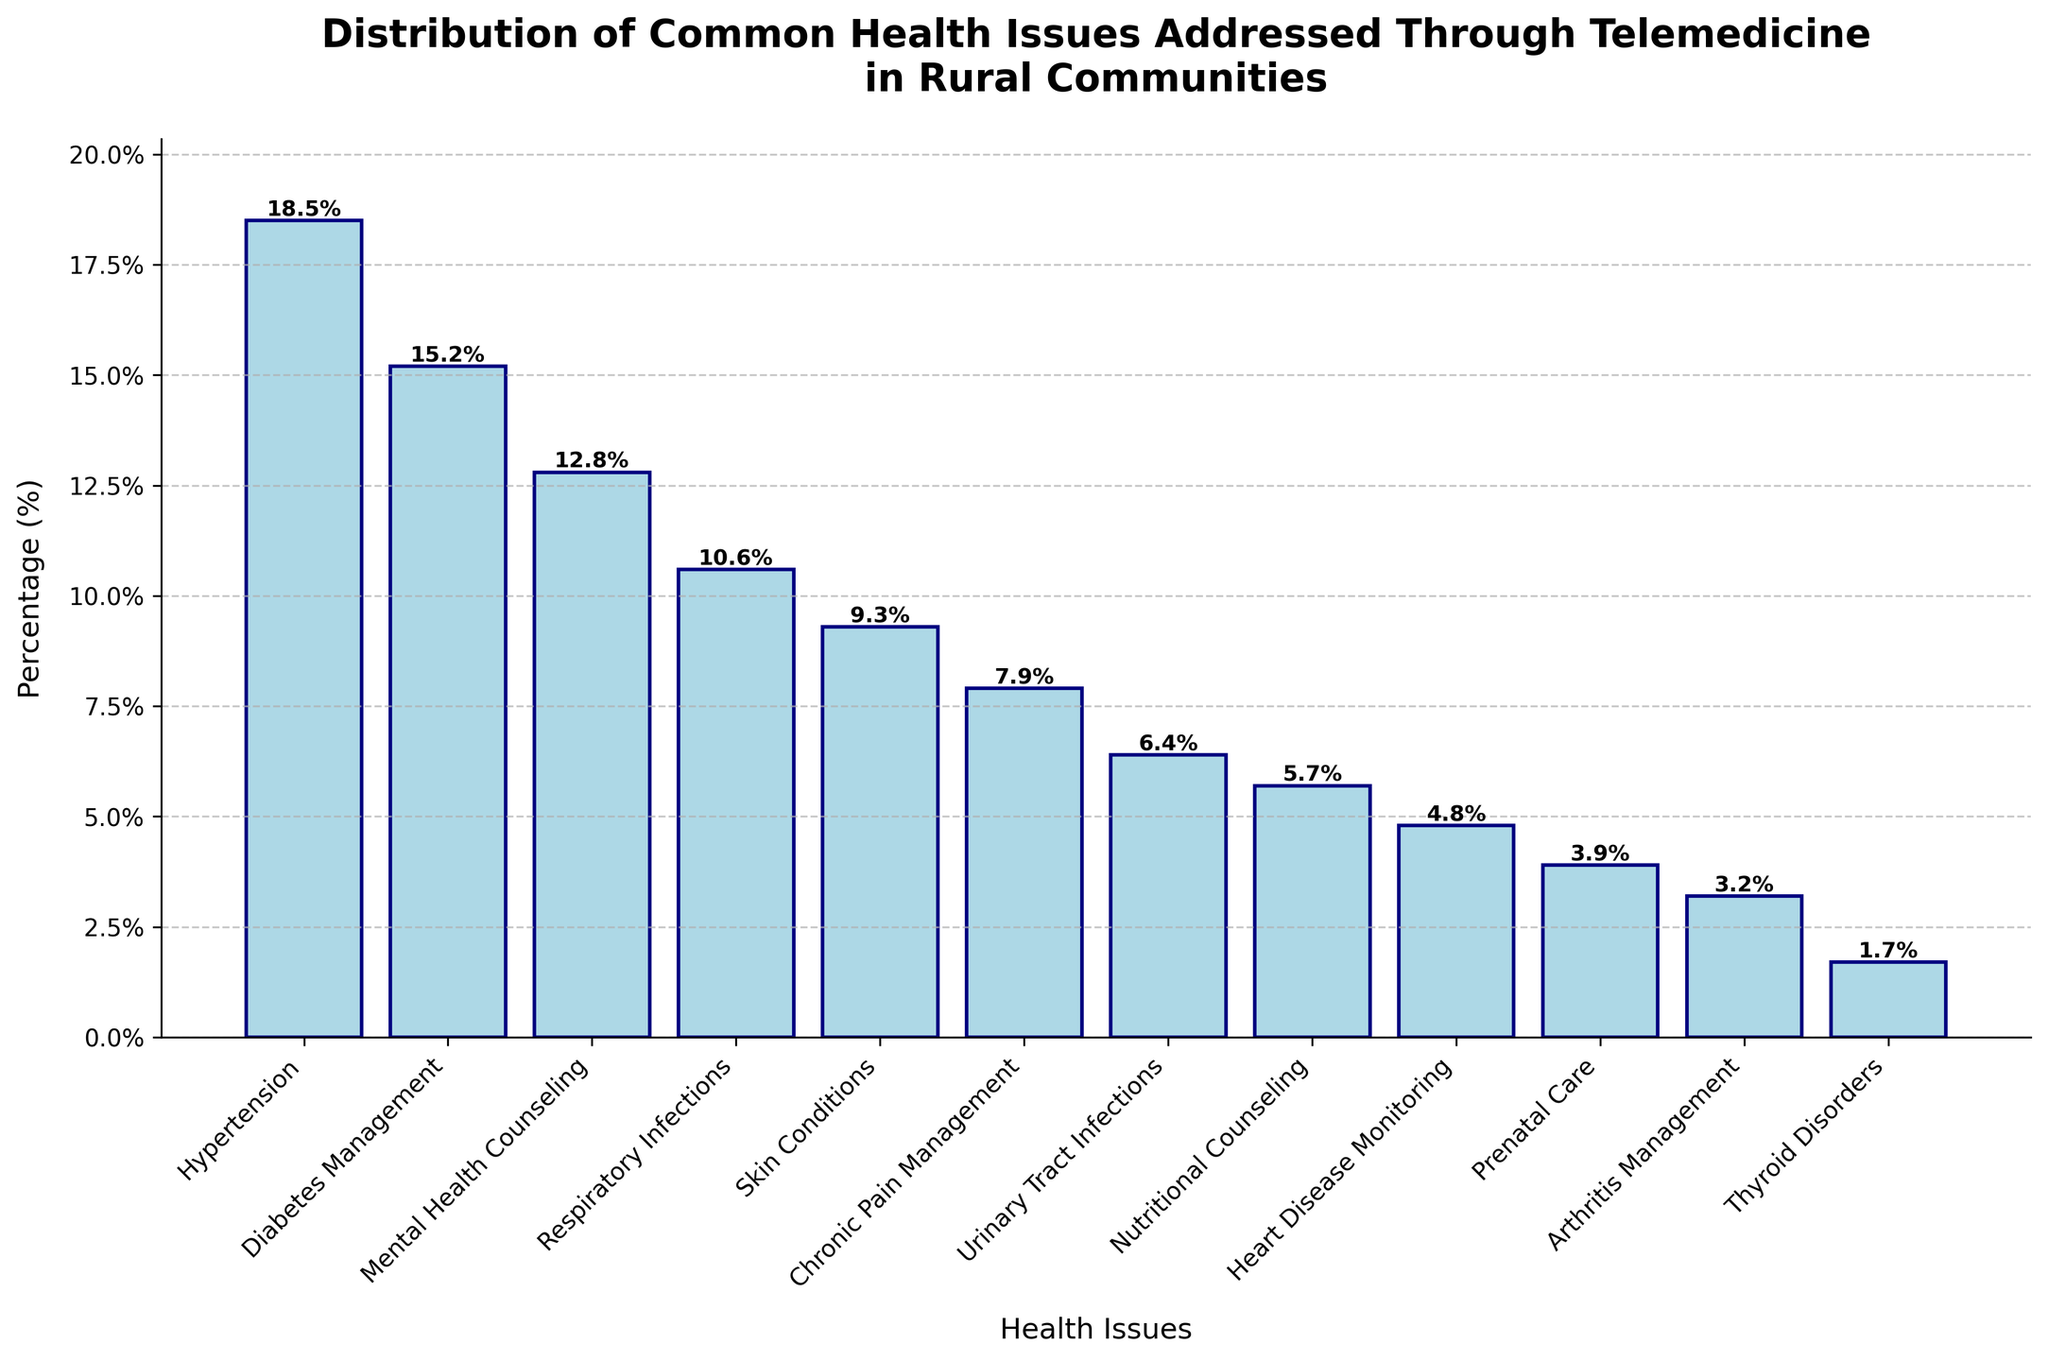What is the most common health issue addressed through telemedicine in rural communities? Hypertension has the highest percentage of cases at 18.5%, as shown by the tallest bar in the chart.
Answer: Hypertension Which health issue has a higher percentage, Respiratory Infections or Mental Health Counseling? Mental Health Counseling has a higher percentage (12.8%) compared to Respiratory Infections (10.6%). This can be seen by comparing the heights of the corresponding bars.
Answer: Mental Health Counseling What is the combined percentage of Hypertension, Diabetes Management, and Mental Health Counseling? Hypertension is 18.5%, Diabetes Management is 15.2%, and Mental Health Counseling is 12.8%. Adding these up gives 18.5 + 15.2 + 12.8 = 46.5%.
Answer: 46.5% How much higher is the percentage of Hypertension compared to Heart Disease Monitoring? The percentage for Hypertension is 18.5%, and for Heart Disease Monitoring, it is 4.8%. Subtract 4.8 from 18.5 to find the difference, which is 18.5 - 4.8 = 13.7%.
Answer: 13.7% Are there more health issues with a percentage higher than 10% or fewer than 10%? There are four health issues with a percentage higher than 10% (Hypertension, Diabetes Management, Mental Health Counseling, and Respiratory Infections), and there are eight issues with a percentage lower than 10%.
Answer: Fewer than 10% Which health issue addressed through telemedicine has the closest percentage to Arthritis Management? Thyroid Disorders with a percentage of 1.7% is the closest to Arthritis Management, which has a percentage of 3.2%.
Answer: Thyroid Disorders What are the percentages for Diabetes Management and Urinary Tract Infections combined? Diabetes Management is 15.2% and Urinary Tract Infections is 6.4%. Adding these together gives 15.2 + 6.4 = 21.6%.
Answer: 21.6% What is the difference in percentage points between Chronic Pain Management and Prenatal Care? Chronic Pain Management is at 7.9% and Prenatal Care is at 3.9%. Subtracting these, 7.9 - 3.9, gives 4.0%.
Answer: 4.0% Which health issue out of Nutritional Counseling and Skin Conditions has the smaller percentage? Nutritional Counseling has a smaller percentage (5.7%) compared to Skin Conditions (9.3%).
Answer: Nutritional Counseling Is the percentage for Thyroid Disorders more or less than half of the percentage for Chronic Pain Management? The percentage for Thyroid Disorders (1.7%) is less than half of the percentage for Chronic Pain Management (7.9%).
Answer: Less 